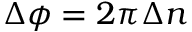Convert formula to latex. <formula><loc_0><loc_0><loc_500><loc_500>\Delta \phi = 2 \pi \Delta n</formula> 